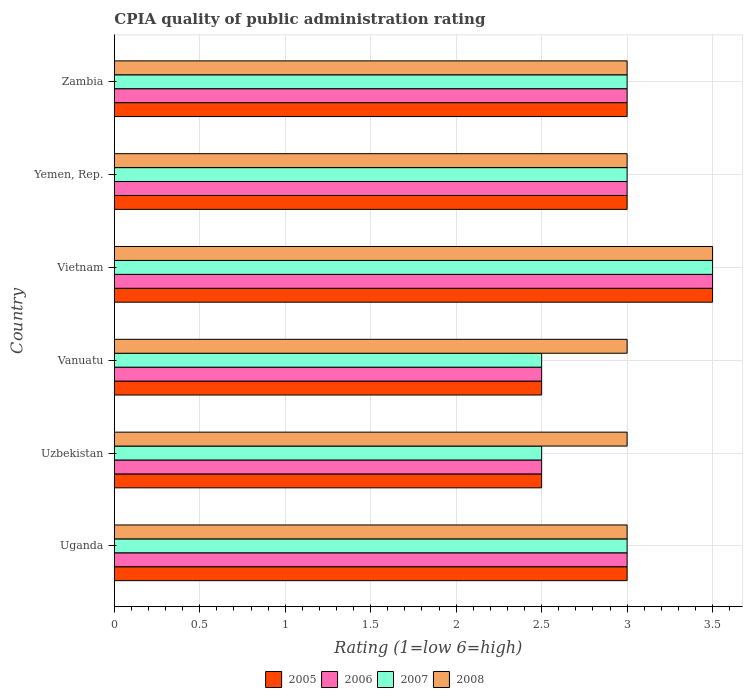Are the number of bars per tick equal to the number of legend labels?
Provide a succinct answer. Yes. What is the label of the 4th group of bars from the top?
Give a very brief answer. Vanuatu. What is the CPIA rating in 2005 in Vanuatu?
Provide a succinct answer. 2.5. In which country was the CPIA rating in 2006 maximum?
Offer a very short reply. Vietnam. In which country was the CPIA rating in 2008 minimum?
Give a very brief answer. Uganda. What is the difference between the CPIA rating in 2008 in Yemen, Rep. and the CPIA rating in 2006 in Zambia?
Your answer should be very brief. 0. What is the average CPIA rating in 2007 per country?
Ensure brevity in your answer.  2.92. In how many countries, is the CPIA rating in 2007 greater than 2.2 ?
Your response must be concise. 6. What is the ratio of the CPIA rating in 2006 in Uzbekistan to that in Zambia?
Make the answer very short. 0.83. Is the CPIA rating in 2006 in Vanuatu less than that in Zambia?
Keep it short and to the point. Yes. Is the difference between the CPIA rating in 2006 in Uganda and Yemen, Rep. greater than the difference between the CPIA rating in 2007 in Uganda and Yemen, Rep.?
Provide a short and direct response. No. What is the difference between the highest and the second highest CPIA rating in 2006?
Make the answer very short. 0.5. Is the sum of the CPIA rating in 2007 in Vietnam and Yemen, Rep. greater than the maximum CPIA rating in 2006 across all countries?
Offer a terse response. Yes. How many bars are there?
Provide a short and direct response. 24. Are all the bars in the graph horizontal?
Your answer should be very brief. Yes. What is the difference between two consecutive major ticks on the X-axis?
Your answer should be very brief. 0.5. What is the title of the graph?
Provide a short and direct response. CPIA quality of public administration rating. Does "1977" appear as one of the legend labels in the graph?
Offer a terse response. No. What is the label or title of the Y-axis?
Provide a succinct answer. Country. What is the Rating (1=low 6=high) in 2008 in Uganda?
Provide a succinct answer. 3. What is the Rating (1=low 6=high) in 2005 in Uzbekistan?
Your answer should be compact. 2.5. What is the Rating (1=low 6=high) in 2005 in Vanuatu?
Provide a succinct answer. 2.5. What is the Rating (1=low 6=high) in 2007 in Vanuatu?
Provide a short and direct response. 2.5. What is the Rating (1=low 6=high) of 2008 in Vanuatu?
Make the answer very short. 3. What is the Rating (1=low 6=high) of 2005 in Vietnam?
Make the answer very short. 3.5. What is the Rating (1=low 6=high) of 2006 in Vietnam?
Offer a terse response. 3.5. What is the Rating (1=low 6=high) in 2006 in Yemen, Rep.?
Your answer should be compact. 3. What is the Rating (1=low 6=high) of 2008 in Yemen, Rep.?
Make the answer very short. 3. What is the Rating (1=low 6=high) of 2007 in Zambia?
Provide a succinct answer. 3. What is the Rating (1=low 6=high) in 2008 in Zambia?
Your response must be concise. 3. Across all countries, what is the maximum Rating (1=low 6=high) of 2005?
Offer a terse response. 3.5. Across all countries, what is the maximum Rating (1=low 6=high) in 2007?
Provide a short and direct response. 3.5. Across all countries, what is the minimum Rating (1=low 6=high) in 2006?
Provide a succinct answer. 2.5. Across all countries, what is the minimum Rating (1=low 6=high) in 2007?
Give a very brief answer. 2.5. Across all countries, what is the minimum Rating (1=low 6=high) of 2008?
Give a very brief answer. 3. What is the total Rating (1=low 6=high) in 2005 in the graph?
Provide a succinct answer. 17.5. What is the total Rating (1=low 6=high) of 2007 in the graph?
Your answer should be compact. 17.5. What is the total Rating (1=low 6=high) in 2008 in the graph?
Provide a short and direct response. 18.5. What is the difference between the Rating (1=low 6=high) in 2005 in Uganda and that in Uzbekistan?
Offer a very short reply. 0.5. What is the difference between the Rating (1=low 6=high) of 2006 in Uganda and that in Uzbekistan?
Provide a short and direct response. 0.5. What is the difference between the Rating (1=low 6=high) of 2007 in Uganda and that in Uzbekistan?
Provide a succinct answer. 0.5. What is the difference between the Rating (1=low 6=high) in 2005 in Uganda and that in Vanuatu?
Your answer should be very brief. 0.5. What is the difference between the Rating (1=low 6=high) in 2006 in Uganda and that in Vanuatu?
Offer a terse response. 0.5. What is the difference between the Rating (1=low 6=high) of 2005 in Uganda and that in Vietnam?
Provide a short and direct response. -0.5. What is the difference between the Rating (1=low 6=high) of 2006 in Uganda and that in Vietnam?
Your answer should be compact. -0.5. What is the difference between the Rating (1=low 6=high) of 2007 in Uganda and that in Vietnam?
Your answer should be very brief. -0.5. What is the difference between the Rating (1=low 6=high) in 2008 in Uganda and that in Vietnam?
Provide a short and direct response. -0.5. What is the difference between the Rating (1=low 6=high) of 2006 in Uganda and that in Yemen, Rep.?
Offer a very short reply. 0. What is the difference between the Rating (1=low 6=high) of 2008 in Uganda and that in Yemen, Rep.?
Provide a succinct answer. 0. What is the difference between the Rating (1=low 6=high) in 2005 in Uganda and that in Zambia?
Provide a succinct answer. 0. What is the difference between the Rating (1=low 6=high) in 2006 in Uganda and that in Zambia?
Ensure brevity in your answer.  0. What is the difference between the Rating (1=low 6=high) in 2006 in Uzbekistan and that in Vanuatu?
Make the answer very short. 0. What is the difference between the Rating (1=low 6=high) of 2007 in Uzbekistan and that in Vanuatu?
Provide a succinct answer. 0. What is the difference between the Rating (1=low 6=high) of 2008 in Uzbekistan and that in Yemen, Rep.?
Provide a succinct answer. 0. What is the difference between the Rating (1=low 6=high) of 2005 in Uzbekistan and that in Zambia?
Your answer should be very brief. -0.5. What is the difference between the Rating (1=low 6=high) in 2006 in Uzbekistan and that in Zambia?
Offer a very short reply. -0.5. What is the difference between the Rating (1=low 6=high) in 2007 in Uzbekistan and that in Zambia?
Offer a terse response. -0.5. What is the difference between the Rating (1=low 6=high) in 2008 in Uzbekistan and that in Zambia?
Your response must be concise. 0. What is the difference between the Rating (1=low 6=high) in 2005 in Vanuatu and that in Vietnam?
Offer a very short reply. -1. What is the difference between the Rating (1=low 6=high) in 2006 in Vanuatu and that in Vietnam?
Give a very brief answer. -1. What is the difference between the Rating (1=low 6=high) in 2007 in Vanuatu and that in Vietnam?
Ensure brevity in your answer.  -1. What is the difference between the Rating (1=low 6=high) of 2006 in Vanuatu and that in Yemen, Rep.?
Your response must be concise. -0.5. What is the difference between the Rating (1=low 6=high) in 2008 in Vanuatu and that in Yemen, Rep.?
Your answer should be very brief. 0. What is the difference between the Rating (1=low 6=high) of 2005 in Vanuatu and that in Zambia?
Ensure brevity in your answer.  -0.5. What is the difference between the Rating (1=low 6=high) in 2005 in Vietnam and that in Yemen, Rep.?
Offer a terse response. 0.5. What is the difference between the Rating (1=low 6=high) of 2008 in Vietnam and that in Yemen, Rep.?
Provide a short and direct response. 0.5. What is the difference between the Rating (1=low 6=high) in 2006 in Vietnam and that in Zambia?
Your answer should be compact. 0.5. What is the difference between the Rating (1=low 6=high) in 2007 in Vietnam and that in Zambia?
Ensure brevity in your answer.  0.5. What is the difference between the Rating (1=low 6=high) of 2008 in Vietnam and that in Zambia?
Keep it short and to the point. 0.5. What is the difference between the Rating (1=low 6=high) in 2006 in Yemen, Rep. and that in Zambia?
Make the answer very short. 0. What is the difference between the Rating (1=low 6=high) of 2007 in Yemen, Rep. and that in Zambia?
Your answer should be compact. 0. What is the difference between the Rating (1=low 6=high) of 2005 in Uganda and the Rating (1=low 6=high) of 2008 in Uzbekistan?
Ensure brevity in your answer.  0. What is the difference between the Rating (1=low 6=high) of 2006 in Uganda and the Rating (1=low 6=high) of 2008 in Uzbekistan?
Ensure brevity in your answer.  0. What is the difference between the Rating (1=low 6=high) in 2005 in Uganda and the Rating (1=low 6=high) in 2007 in Vanuatu?
Your response must be concise. 0.5. What is the difference between the Rating (1=low 6=high) in 2006 in Uganda and the Rating (1=low 6=high) in 2007 in Vanuatu?
Provide a short and direct response. 0.5. What is the difference between the Rating (1=low 6=high) in 2006 in Uganda and the Rating (1=low 6=high) in 2008 in Vanuatu?
Make the answer very short. 0. What is the difference between the Rating (1=low 6=high) of 2007 in Uganda and the Rating (1=low 6=high) of 2008 in Vanuatu?
Give a very brief answer. 0. What is the difference between the Rating (1=low 6=high) of 2005 in Uganda and the Rating (1=low 6=high) of 2006 in Vietnam?
Ensure brevity in your answer.  -0.5. What is the difference between the Rating (1=low 6=high) of 2005 in Uganda and the Rating (1=low 6=high) of 2008 in Vietnam?
Give a very brief answer. -0.5. What is the difference between the Rating (1=low 6=high) in 2007 in Uganda and the Rating (1=low 6=high) in 2008 in Vietnam?
Provide a short and direct response. -0.5. What is the difference between the Rating (1=low 6=high) of 2005 in Uganda and the Rating (1=low 6=high) of 2007 in Yemen, Rep.?
Give a very brief answer. 0. What is the difference between the Rating (1=low 6=high) in 2005 in Uganda and the Rating (1=low 6=high) in 2006 in Zambia?
Provide a short and direct response. 0. What is the difference between the Rating (1=low 6=high) in 2005 in Uganda and the Rating (1=low 6=high) in 2007 in Zambia?
Your answer should be very brief. 0. What is the difference between the Rating (1=low 6=high) of 2006 in Uganda and the Rating (1=low 6=high) of 2008 in Zambia?
Offer a terse response. 0. What is the difference between the Rating (1=low 6=high) of 2007 in Uganda and the Rating (1=low 6=high) of 2008 in Zambia?
Offer a terse response. 0. What is the difference between the Rating (1=low 6=high) in 2005 in Uzbekistan and the Rating (1=low 6=high) in 2007 in Vanuatu?
Ensure brevity in your answer.  0. What is the difference between the Rating (1=low 6=high) of 2005 in Uzbekistan and the Rating (1=low 6=high) of 2006 in Vietnam?
Give a very brief answer. -1. What is the difference between the Rating (1=low 6=high) of 2005 in Uzbekistan and the Rating (1=low 6=high) of 2007 in Vietnam?
Ensure brevity in your answer.  -1. What is the difference between the Rating (1=low 6=high) of 2005 in Uzbekistan and the Rating (1=low 6=high) of 2008 in Vietnam?
Offer a very short reply. -1. What is the difference between the Rating (1=low 6=high) of 2006 in Uzbekistan and the Rating (1=low 6=high) of 2007 in Vietnam?
Offer a very short reply. -1. What is the difference between the Rating (1=low 6=high) in 2006 in Uzbekistan and the Rating (1=low 6=high) in 2008 in Vietnam?
Offer a terse response. -1. What is the difference between the Rating (1=low 6=high) in 2007 in Uzbekistan and the Rating (1=low 6=high) in 2008 in Vietnam?
Offer a very short reply. -1. What is the difference between the Rating (1=low 6=high) of 2005 in Uzbekistan and the Rating (1=low 6=high) of 2006 in Yemen, Rep.?
Your answer should be very brief. -0.5. What is the difference between the Rating (1=low 6=high) of 2006 in Uzbekistan and the Rating (1=low 6=high) of 2007 in Yemen, Rep.?
Give a very brief answer. -0.5. What is the difference between the Rating (1=low 6=high) in 2006 in Uzbekistan and the Rating (1=low 6=high) in 2008 in Yemen, Rep.?
Offer a terse response. -0.5. What is the difference between the Rating (1=low 6=high) in 2005 in Uzbekistan and the Rating (1=low 6=high) in 2006 in Zambia?
Give a very brief answer. -0.5. What is the difference between the Rating (1=low 6=high) of 2006 in Uzbekistan and the Rating (1=low 6=high) of 2007 in Zambia?
Your response must be concise. -0.5. What is the difference between the Rating (1=low 6=high) of 2006 in Uzbekistan and the Rating (1=low 6=high) of 2008 in Zambia?
Offer a terse response. -0.5. What is the difference between the Rating (1=low 6=high) in 2005 in Vanuatu and the Rating (1=low 6=high) in 2006 in Vietnam?
Provide a succinct answer. -1. What is the difference between the Rating (1=low 6=high) of 2005 in Vanuatu and the Rating (1=low 6=high) of 2007 in Vietnam?
Your response must be concise. -1. What is the difference between the Rating (1=low 6=high) of 2006 in Vanuatu and the Rating (1=low 6=high) of 2008 in Vietnam?
Ensure brevity in your answer.  -1. What is the difference between the Rating (1=low 6=high) of 2007 in Vanuatu and the Rating (1=low 6=high) of 2008 in Vietnam?
Offer a terse response. -1. What is the difference between the Rating (1=low 6=high) of 2005 in Vanuatu and the Rating (1=low 6=high) of 2006 in Yemen, Rep.?
Ensure brevity in your answer.  -0.5. What is the difference between the Rating (1=low 6=high) of 2005 in Vanuatu and the Rating (1=low 6=high) of 2006 in Zambia?
Offer a very short reply. -0.5. What is the difference between the Rating (1=low 6=high) in 2005 in Vanuatu and the Rating (1=low 6=high) in 2007 in Zambia?
Ensure brevity in your answer.  -0.5. What is the difference between the Rating (1=low 6=high) of 2005 in Vanuatu and the Rating (1=low 6=high) of 2008 in Zambia?
Provide a short and direct response. -0.5. What is the difference between the Rating (1=low 6=high) of 2006 in Vanuatu and the Rating (1=low 6=high) of 2007 in Zambia?
Make the answer very short. -0.5. What is the difference between the Rating (1=low 6=high) of 2006 in Vanuatu and the Rating (1=low 6=high) of 2008 in Zambia?
Your answer should be very brief. -0.5. What is the difference between the Rating (1=low 6=high) in 2005 in Vietnam and the Rating (1=low 6=high) in 2006 in Yemen, Rep.?
Your answer should be very brief. 0.5. What is the difference between the Rating (1=low 6=high) in 2005 in Vietnam and the Rating (1=low 6=high) in 2007 in Yemen, Rep.?
Keep it short and to the point. 0.5. What is the difference between the Rating (1=low 6=high) in 2006 in Vietnam and the Rating (1=low 6=high) in 2007 in Yemen, Rep.?
Make the answer very short. 0.5. What is the difference between the Rating (1=low 6=high) of 2006 in Vietnam and the Rating (1=low 6=high) of 2008 in Yemen, Rep.?
Offer a terse response. 0.5. What is the difference between the Rating (1=low 6=high) of 2007 in Vietnam and the Rating (1=low 6=high) of 2008 in Yemen, Rep.?
Keep it short and to the point. 0.5. What is the difference between the Rating (1=low 6=high) of 2006 in Vietnam and the Rating (1=low 6=high) of 2007 in Zambia?
Ensure brevity in your answer.  0.5. What is the difference between the Rating (1=low 6=high) of 2005 in Yemen, Rep. and the Rating (1=low 6=high) of 2008 in Zambia?
Keep it short and to the point. 0. What is the average Rating (1=low 6=high) of 2005 per country?
Make the answer very short. 2.92. What is the average Rating (1=low 6=high) in 2006 per country?
Offer a very short reply. 2.92. What is the average Rating (1=low 6=high) of 2007 per country?
Give a very brief answer. 2.92. What is the average Rating (1=low 6=high) in 2008 per country?
Your answer should be compact. 3.08. What is the difference between the Rating (1=low 6=high) of 2005 and Rating (1=low 6=high) of 2007 in Uganda?
Offer a terse response. 0. What is the difference between the Rating (1=low 6=high) of 2006 and Rating (1=low 6=high) of 2007 in Uganda?
Ensure brevity in your answer.  0. What is the difference between the Rating (1=low 6=high) in 2005 and Rating (1=low 6=high) in 2006 in Uzbekistan?
Your answer should be compact. 0. What is the difference between the Rating (1=low 6=high) in 2005 and Rating (1=low 6=high) in 2007 in Uzbekistan?
Your answer should be very brief. 0. What is the difference between the Rating (1=low 6=high) of 2005 and Rating (1=low 6=high) of 2007 in Vanuatu?
Offer a terse response. 0. What is the difference between the Rating (1=low 6=high) of 2005 and Rating (1=low 6=high) of 2008 in Vanuatu?
Provide a short and direct response. -0.5. What is the difference between the Rating (1=low 6=high) of 2006 and Rating (1=low 6=high) of 2008 in Vanuatu?
Offer a terse response. -0.5. What is the difference between the Rating (1=low 6=high) in 2007 and Rating (1=low 6=high) in 2008 in Vanuatu?
Ensure brevity in your answer.  -0.5. What is the difference between the Rating (1=low 6=high) in 2005 and Rating (1=low 6=high) in 2006 in Vietnam?
Keep it short and to the point. 0. What is the difference between the Rating (1=low 6=high) of 2005 and Rating (1=low 6=high) of 2007 in Vietnam?
Your answer should be compact. 0. What is the difference between the Rating (1=low 6=high) in 2005 and Rating (1=low 6=high) in 2008 in Vietnam?
Provide a succinct answer. 0. What is the difference between the Rating (1=low 6=high) of 2006 and Rating (1=low 6=high) of 2007 in Vietnam?
Your response must be concise. 0. What is the difference between the Rating (1=low 6=high) in 2006 and Rating (1=low 6=high) in 2008 in Vietnam?
Offer a terse response. 0. What is the difference between the Rating (1=low 6=high) of 2005 and Rating (1=low 6=high) of 2006 in Yemen, Rep.?
Make the answer very short. 0. What is the difference between the Rating (1=low 6=high) of 2006 and Rating (1=low 6=high) of 2007 in Yemen, Rep.?
Your response must be concise. 0. What is the difference between the Rating (1=low 6=high) of 2005 and Rating (1=low 6=high) of 2006 in Zambia?
Offer a terse response. 0. What is the difference between the Rating (1=low 6=high) in 2006 and Rating (1=low 6=high) in 2007 in Zambia?
Keep it short and to the point. 0. What is the difference between the Rating (1=low 6=high) in 2006 and Rating (1=low 6=high) in 2008 in Zambia?
Provide a short and direct response. 0. What is the ratio of the Rating (1=low 6=high) of 2005 in Uganda to that in Uzbekistan?
Ensure brevity in your answer.  1.2. What is the ratio of the Rating (1=low 6=high) of 2007 in Uganda to that in Uzbekistan?
Offer a terse response. 1.2. What is the ratio of the Rating (1=low 6=high) in 2008 in Uganda to that in Uzbekistan?
Ensure brevity in your answer.  1. What is the ratio of the Rating (1=low 6=high) in 2005 in Uganda to that in Vanuatu?
Ensure brevity in your answer.  1.2. What is the ratio of the Rating (1=low 6=high) of 2007 in Uganda to that in Vanuatu?
Provide a short and direct response. 1.2. What is the ratio of the Rating (1=low 6=high) of 2006 in Uganda to that in Yemen, Rep.?
Give a very brief answer. 1. What is the ratio of the Rating (1=low 6=high) of 2006 in Uganda to that in Zambia?
Give a very brief answer. 1. What is the ratio of the Rating (1=low 6=high) in 2007 in Uganda to that in Zambia?
Your answer should be very brief. 1. What is the ratio of the Rating (1=low 6=high) in 2005 in Uzbekistan to that in Vanuatu?
Your response must be concise. 1. What is the ratio of the Rating (1=low 6=high) of 2007 in Uzbekistan to that in Vanuatu?
Offer a terse response. 1. What is the ratio of the Rating (1=low 6=high) in 2006 in Uzbekistan to that in Vietnam?
Give a very brief answer. 0.71. What is the ratio of the Rating (1=low 6=high) in 2008 in Uzbekistan to that in Vietnam?
Your response must be concise. 0.86. What is the ratio of the Rating (1=low 6=high) in 2007 in Uzbekistan to that in Yemen, Rep.?
Give a very brief answer. 0.83. What is the ratio of the Rating (1=low 6=high) of 2008 in Uzbekistan to that in Yemen, Rep.?
Make the answer very short. 1. What is the ratio of the Rating (1=low 6=high) of 2005 in Uzbekistan to that in Zambia?
Make the answer very short. 0.83. What is the ratio of the Rating (1=low 6=high) in 2007 in Vanuatu to that in Vietnam?
Ensure brevity in your answer.  0.71. What is the ratio of the Rating (1=low 6=high) in 2008 in Vanuatu to that in Vietnam?
Provide a succinct answer. 0.86. What is the ratio of the Rating (1=low 6=high) in 2005 in Vanuatu to that in Yemen, Rep.?
Offer a terse response. 0.83. What is the ratio of the Rating (1=low 6=high) of 2006 in Vanuatu to that in Yemen, Rep.?
Provide a succinct answer. 0.83. What is the ratio of the Rating (1=low 6=high) in 2007 in Vanuatu to that in Yemen, Rep.?
Ensure brevity in your answer.  0.83. What is the ratio of the Rating (1=low 6=high) in 2008 in Vanuatu to that in Yemen, Rep.?
Your answer should be compact. 1. What is the ratio of the Rating (1=low 6=high) in 2007 in Vanuatu to that in Zambia?
Make the answer very short. 0.83. What is the ratio of the Rating (1=low 6=high) in 2005 in Vietnam to that in Yemen, Rep.?
Offer a very short reply. 1.17. What is the ratio of the Rating (1=low 6=high) of 2006 in Vietnam to that in Yemen, Rep.?
Provide a short and direct response. 1.17. What is the ratio of the Rating (1=low 6=high) of 2007 in Vietnam to that in Yemen, Rep.?
Provide a succinct answer. 1.17. What is the ratio of the Rating (1=low 6=high) in 2008 in Vietnam to that in Yemen, Rep.?
Give a very brief answer. 1.17. What is the ratio of the Rating (1=low 6=high) of 2005 in Vietnam to that in Zambia?
Ensure brevity in your answer.  1.17. What is the ratio of the Rating (1=low 6=high) in 2006 in Vietnam to that in Zambia?
Your answer should be very brief. 1.17. What is the ratio of the Rating (1=low 6=high) of 2005 in Yemen, Rep. to that in Zambia?
Provide a short and direct response. 1. What is the ratio of the Rating (1=low 6=high) of 2006 in Yemen, Rep. to that in Zambia?
Ensure brevity in your answer.  1. What is the ratio of the Rating (1=low 6=high) in 2007 in Yemen, Rep. to that in Zambia?
Offer a very short reply. 1. What is the difference between the highest and the second highest Rating (1=low 6=high) of 2006?
Your answer should be compact. 0.5. What is the difference between the highest and the lowest Rating (1=low 6=high) in 2005?
Give a very brief answer. 1. What is the difference between the highest and the lowest Rating (1=low 6=high) of 2007?
Your answer should be compact. 1. 